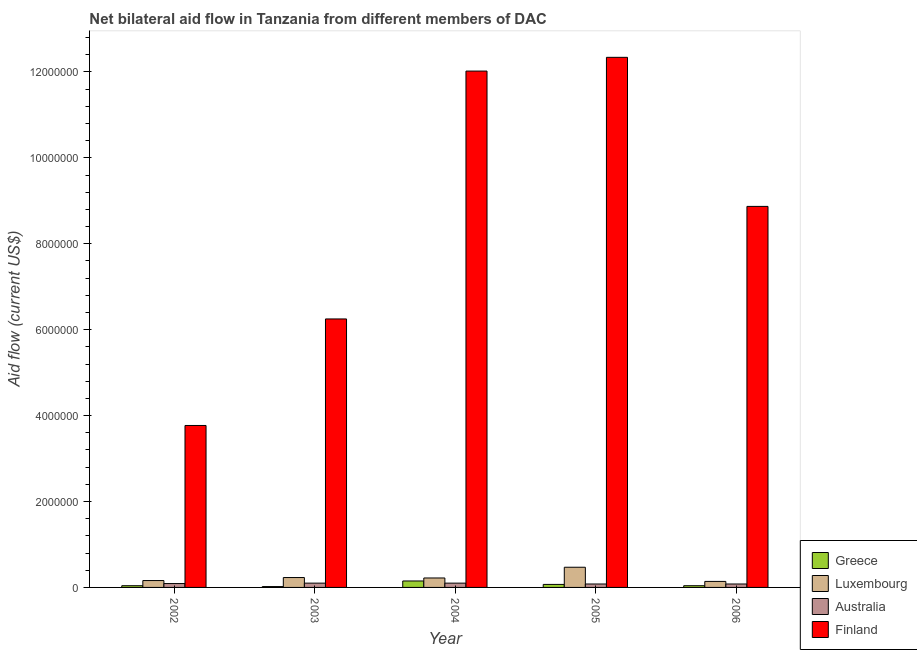How many different coloured bars are there?
Your answer should be compact. 4. How many groups of bars are there?
Provide a succinct answer. 5. Are the number of bars on each tick of the X-axis equal?
Provide a short and direct response. Yes. How many bars are there on the 4th tick from the left?
Give a very brief answer. 4. What is the label of the 3rd group of bars from the left?
Make the answer very short. 2004. In how many cases, is the number of bars for a given year not equal to the number of legend labels?
Your response must be concise. 0. What is the amount of aid given by finland in 2003?
Provide a short and direct response. 6.25e+06. Across all years, what is the maximum amount of aid given by luxembourg?
Offer a very short reply. 4.70e+05. Across all years, what is the minimum amount of aid given by australia?
Your answer should be compact. 8.00e+04. In which year was the amount of aid given by greece minimum?
Offer a terse response. 2003. What is the total amount of aid given by australia in the graph?
Provide a succinct answer. 4.50e+05. What is the difference between the amount of aid given by finland in 2002 and that in 2004?
Provide a succinct answer. -8.25e+06. What is the average amount of aid given by luxembourg per year?
Give a very brief answer. 2.44e+05. In the year 2004, what is the difference between the amount of aid given by luxembourg and amount of aid given by australia?
Provide a succinct answer. 0. What is the difference between the highest and the lowest amount of aid given by luxembourg?
Your answer should be very brief. 3.30e+05. In how many years, is the amount of aid given by australia greater than the average amount of aid given by australia taken over all years?
Offer a terse response. 2. Is the sum of the amount of aid given by greece in 2002 and 2004 greater than the maximum amount of aid given by luxembourg across all years?
Offer a terse response. Yes. How many bars are there?
Ensure brevity in your answer.  20. Does the graph contain any zero values?
Provide a succinct answer. No. Does the graph contain grids?
Provide a succinct answer. No. What is the title of the graph?
Your answer should be very brief. Net bilateral aid flow in Tanzania from different members of DAC. What is the Aid flow (current US$) in Luxembourg in 2002?
Give a very brief answer. 1.60e+05. What is the Aid flow (current US$) of Australia in 2002?
Provide a succinct answer. 9.00e+04. What is the Aid flow (current US$) in Finland in 2002?
Your answer should be compact. 3.77e+06. What is the Aid flow (current US$) of Australia in 2003?
Offer a terse response. 1.00e+05. What is the Aid flow (current US$) of Finland in 2003?
Provide a short and direct response. 6.25e+06. What is the Aid flow (current US$) in Luxembourg in 2004?
Ensure brevity in your answer.  2.20e+05. What is the Aid flow (current US$) of Finland in 2004?
Keep it short and to the point. 1.20e+07. What is the Aid flow (current US$) of Finland in 2005?
Offer a very short reply. 1.23e+07. What is the Aid flow (current US$) in Finland in 2006?
Give a very brief answer. 8.87e+06. Across all years, what is the maximum Aid flow (current US$) of Greece?
Your answer should be compact. 1.50e+05. Across all years, what is the maximum Aid flow (current US$) in Finland?
Make the answer very short. 1.23e+07. Across all years, what is the minimum Aid flow (current US$) in Finland?
Your answer should be very brief. 3.77e+06. What is the total Aid flow (current US$) in Greece in the graph?
Give a very brief answer. 3.20e+05. What is the total Aid flow (current US$) of Luxembourg in the graph?
Provide a short and direct response. 1.22e+06. What is the total Aid flow (current US$) in Finland in the graph?
Offer a terse response. 4.32e+07. What is the difference between the Aid flow (current US$) of Greece in 2002 and that in 2003?
Ensure brevity in your answer.  2.00e+04. What is the difference between the Aid flow (current US$) in Luxembourg in 2002 and that in 2003?
Provide a succinct answer. -7.00e+04. What is the difference between the Aid flow (current US$) in Finland in 2002 and that in 2003?
Ensure brevity in your answer.  -2.48e+06. What is the difference between the Aid flow (current US$) of Luxembourg in 2002 and that in 2004?
Your answer should be compact. -6.00e+04. What is the difference between the Aid flow (current US$) of Australia in 2002 and that in 2004?
Provide a succinct answer. -10000. What is the difference between the Aid flow (current US$) in Finland in 2002 and that in 2004?
Provide a short and direct response. -8.25e+06. What is the difference between the Aid flow (current US$) in Luxembourg in 2002 and that in 2005?
Ensure brevity in your answer.  -3.10e+05. What is the difference between the Aid flow (current US$) of Finland in 2002 and that in 2005?
Make the answer very short. -8.57e+06. What is the difference between the Aid flow (current US$) of Greece in 2002 and that in 2006?
Ensure brevity in your answer.  0. What is the difference between the Aid flow (current US$) of Finland in 2002 and that in 2006?
Your answer should be very brief. -5.10e+06. What is the difference between the Aid flow (current US$) in Greece in 2003 and that in 2004?
Give a very brief answer. -1.30e+05. What is the difference between the Aid flow (current US$) of Australia in 2003 and that in 2004?
Your response must be concise. 0. What is the difference between the Aid flow (current US$) of Finland in 2003 and that in 2004?
Make the answer very short. -5.77e+06. What is the difference between the Aid flow (current US$) of Finland in 2003 and that in 2005?
Your answer should be compact. -6.09e+06. What is the difference between the Aid flow (current US$) in Greece in 2003 and that in 2006?
Ensure brevity in your answer.  -2.00e+04. What is the difference between the Aid flow (current US$) of Australia in 2003 and that in 2006?
Provide a succinct answer. 2.00e+04. What is the difference between the Aid flow (current US$) in Finland in 2003 and that in 2006?
Keep it short and to the point. -2.62e+06. What is the difference between the Aid flow (current US$) in Greece in 2004 and that in 2005?
Offer a terse response. 8.00e+04. What is the difference between the Aid flow (current US$) of Luxembourg in 2004 and that in 2005?
Your answer should be compact. -2.50e+05. What is the difference between the Aid flow (current US$) in Finland in 2004 and that in 2005?
Provide a succinct answer. -3.20e+05. What is the difference between the Aid flow (current US$) of Finland in 2004 and that in 2006?
Provide a short and direct response. 3.15e+06. What is the difference between the Aid flow (current US$) in Greece in 2005 and that in 2006?
Offer a terse response. 3.00e+04. What is the difference between the Aid flow (current US$) in Australia in 2005 and that in 2006?
Your response must be concise. 0. What is the difference between the Aid flow (current US$) of Finland in 2005 and that in 2006?
Your answer should be compact. 3.47e+06. What is the difference between the Aid flow (current US$) in Greece in 2002 and the Aid flow (current US$) in Luxembourg in 2003?
Offer a very short reply. -1.90e+05. What is the difference between the Aid flow (current US$) of Greece in 2002 and the Aid flow (current US$) of Finland in 2003?
Provide a succinct answer. -6.21e+06. What is the difference between the Aid flow (current US$) of Luxembourg in 2002 and the Aid flow (current US$) of Australia in 2003?
Your response must be concise. 6.00e+04. What is the difference between the Aid flow (current US$) in Luxembourg in 2002 and the Aid flow (current US$) in Finland in 2003?
Give a very brief answer. -6.09e+06. What is the difference between the Aid flow (current US$) in Australia in 2002 and the Aid flow (current US$) in Finland in 2003?
Provide a succinct answer. -6.16e+06. What is the difference between the Aid flow (current US$) in Greece in 2002 and the Aid flow (current US$) in Australia in 2004?
Keep it short and to the point. -6.00e+04. What is the difference between the Aid flow (current US$) in Greece in 2002 and the Aid flow (current US$) in Finland in 2004?
Your response must be concise. -1.20e+07. What is the difference between the Aid flow (current US$) in Luxembourg in 2002 and the Aid flow (current US$) in Finland in 2004?
Make the answer very short. -1.19e+07. What is the difference between the Aid flow (current US$) of Australia in 2002 and the Aid flow (current US$) of Finland in 2004?
Your answer should be very brief. -1.19e+07. What is the difference between the Aid flow (current US$) of Greece in 2002 and the Aid flow (current US$) of Luxembourg in 2005?
Your response must be concise. -4.30e+05. What is the difference between the Aid flow (current US$) in Greece in 2002 and the Aid flow (current US$) in Australia in 2005?
Provide a short and direct response. -4.00e+04. What is the difference between the Aid flow (current US$) in Greece in 2002 and the Aid flow (current US$) in Finland in 2005?
Offer a very short reply. -1.23e+07. What is the difference between the Aid flow (current US$) in Luxembourg in 2002 and the Aid flow (current US$) in Finland in 2005?
Make the answer very short. -1.22e+07. What is the difference between the Aid flow (current US$) of Australia in 2002 and the Aid flow (current US$) of Finland in 2005?
Your answer should be very brief. -1.22e+07. What is the difference between the Aid flow (current US$) in Greece in 2002 and the Aid flow (current US$) in Finland in 2006?
Offer a terse response. -8.83e+06. What is the difference between the Aid flow (current US$) in Luxembourg in 2002 and the Aid flow (current US$) in Finland in 2006?
Provide a short and direct response. -8.71e+06. What is the difference between the Aid flow (current US$) of Australia in 2002 and the Aid flow (current US$) of Finland in 2006?
Your answer should be very brief. -8.78e+06. What is the difference between the Aid flow (current US$) of Greece in 2003 and the Aid flow (current US$) of Australia in 2004?
Your response must be concise. -8.00e+04. What is the difference between the Aid flow (current US$) of Greece in 2003 and the Aid flow (current US$) of Finland in 2004?
Provide a short and direct response. -1.20e+07. What is the difference between the Aid flow (current US$) of Luxembourg in 2003 and the Aid flow (current US$) of Australia in 2004?
Keep it short and to the point. 1.30e+05. What is the difference between the Aid flow (current US$) in Luxembourg in 2003 and the Aid flow (current US$) in Finland in 2004?
Ensure brevity in your answer.  -1.18e+07. What is the difference between the Aid flow (current US$) of Australia in 2003 and the Aid flow (current US$) of Finland in 2004?
Keep it short and to the point. -1.19e+07. What is the difference between the Aid flow (current US$) in Greece in 2003 and the Aid flow (current US$) in Luxembourg in 2005?
Keep it short and to the point. -4.50e+05. What is the difference between the Aid flow (current US$) of Greece in 2003 and the Aid flow (current US$) of Finland in 2005?
Provide a succinct answer. -1.23e+07. What is the difference between the Aid flow (current US$) of Luxembourg in 2003 and the Aid flow (current US$) of Finland in 2005?
Your response must be concise. -1.21e+07. What is the difference between the Aid flow (current US$) of Australia in 2003 and the Aid flow (current US$) of Finland in 2005?
Your answer should be compact. -1.22e+07. What is the difference between the Aid flow (current US$) in Greece in 2003 and the Aid flow (current US$) in Luxembourg in 2006?
Offer a very short reply. -1.20e+05. What is the difference between the Aid flow (current US$) of Greece in 2003 and the Aid flow (current US$) of Finland in 2006?
Your answer should be compact. -8.85e+06. What is the difference between the Aid flow (current US$) of Luxembourg in 2003 and the Aid flow (current US$) of Finland in 2006?
Keep it short and to the point. -8.64e+06. What is the difference between the Aid flow (current US$) of Australia in 2003 and the Aid flow (current US$) of Finland in 2006?
Offer a very short reply. -8.77e+06. What is the difference between the Aid flow (current US$) in Greece in 2004 and the Aid flow (current US$) in Luxembourg in 2005?
Provide a short and direct response. -3.20e+05. What is the difference between the Aid flow (current US$) in Greece in 2004 and the Aid flow (current US$) in Australia in 2005?
Keep it short and to the point. 7.00e+04. What is the difference between the Aid flow (current US$) in Greece in 2004 and the Aid flow (current US$) in Finland in 2005?
Provide a succinct answer. -1.22e+07. What is the difference between the Aid flow (current US$) in Luxembourg in 2004 and the Aid flow (current US$) in Australia in 2005?
Give a very brief answer. 1.40e+05. What is the difference between the Aid flow (current US$) in Luxembourg in 2004 and the Aid flow (current US$) in Finland in 2005?
Offer a very short reply. -1.21e+07. What is the difference between the Aid flow (current US$) in Australia in 2004 and the Aid flow (current US$) in Finland in 2005?
Your answer should be very brief. -1.22e+07. What is the difference between the Aid flow (current US$) of Greece in 2004 and the Aid flow (current US$) of Australia in 2006?
Keep it short and to the point. 7.00e+04. What is the difference between the Aid flow (current US$) in Greece in 2004 and the Aid flow (current US$) in Finland in 2006?
Your answer should be very brief. -8.72e+06. What is the difference between the Aid flow (current US$) in Luxembourg in 2004 and the Aid flow (current US$) in Finland in 2006?
Your answer should be compact. -8.65e+06. What is the difference between the Aid flow (current US$) of Australia in 2004 and the Aid flow (current US$) of Finland in 2006?
Offer a very short reply. -8.77e+06. What is the difference between the Aid flow (current US$) of Greece in 2005 and the Aid flow (current US$) of Finland in 2006?
Your answer should be compact. -8.80e+06. What is the difference between the Aid flow (current US$) of Luxembourg in 2005 and the Aid flow (current US$) of Finland in 2006?
Give a very brief answer. -8.40e+06. What is the difference between the Aid flow (current US$) in Australia in 2005 and the Aid flow (current US$) in Finland in 2006?
Provide a short and direct response. -8.79e+06. What is the average Aid flow (current US$) in Greece per year?
Give a very brief answer. 6.40e+04. What is the average Aid flow (current US$) in Luxembourg per year?
Provide a short and direct response. 2.44e+05. What is the average Aid flow (current US$) of Finland per year?
Keep it short and to the point. 8.65e+06. In the year 2002, what is the difference between the Aid flow (current US$) in Greece and Aid flow (current US$) in Australia?
Keep it short and to the point. -5.00e+04. In the year 2002, what is the difference between the Aid flow (current US$) of Greece and Aid flow (current US$) of Finland?
Provide a short and direct response. -3.73e+06. In the year 2002, what is the difference between the Aid flow (current US$) in Luxembourg and Aid flow (current US$) in Finland?
Give a very brief answer. -3.61e+06. In the year 2002, what is the difference between the Aid flow (current US$) in Australia and Aid flow (current US$) in Finland?
Your response must be concise. -3.68e+06. In the year 2003, what is the difference between the Aid flow (current US$) in Greece and Aid flow (current US$) in Luxembourg?
Provide a succinct answer. -2.10e+05. In the year 2003, what is the difference between the Aid flow (current US$) of Greece and Aid flow (current US$) of Finland?
Your response must be concise. -6.23e+06. In the year 2003, what is the difference between the Aid flow (current US$) in Luxembourg and Aid flow (current US$) in Finland?
Keep it short and to the point. -6.02e+06. In the year 2003, what is the difference between the Aid flow (current US$) in Australia and Aid flow (current US$) in Finland?
Offer a terse response. -6.15e+06. In the year 2004, what is the difference between the Aid flow (current US$) of Greece and Aid flow (current US$) of Australia?
Make the answer very short. 5.00e+04. In the year 2004, what is the difference between the Aid flow (current US$) of Greece and Aid flow (current US$) of Finland?
Offer a terse response. -1.19e+07. In the year 2004, what is the difference between the Aid flow (current US$) of Luxembourg and Aid flow (current US$) of Australia?
Give a very brief answer. 1.20e+05. In the year 2004, what is the difference between the Aid flow (current US$) of Luxembourg and Aid flow (current US$) of Finland?
Your answer should be very brief. -1.18e+07. In the year 2004, what is the difference between the Aid flow (current US$) of Australia and Aid flow (current US$) of Finland?
Your response must be concise. -1.19e+07. In the year 2005, what is the difference between the Aid flow (current US$) in Greece and Aid flow (current US$) in Luxembourg?
Offer a very short reply. -4.00e+05. In the year 2005, what is the difference between the Aid flow (current US$) of Greece and Aid flow (current US$) of Finland?
Keep it short and to the point. -1.23e+07. In the year 2005, what is the difference between the Aid flow (current US$) of Luxembourg and Aid flow (current US$) of Australia?
Keep it short and to the point. 3.90e+05. In the year 2005, what is the difference between the Aid flow (current US$) of Luxembourg and Aid flow (current US$) of Finland?
Offer a very short reply. -1.19e+07. In the year 2005, what is the difference between the Aid flow (current US$) in Australia and Aid flow (current US$) in Finland?
Provide a succinct answer. -1.23e+07. In the year 2006, what is the difference between the Aid flow (current US$) of Greece and Aid flow (current US$) of Finland?
Offer a very short reply. -8.83e+06. In the year 2006, what is the difference between the Aid flow (current US$) in Luxembourg and Aid flow (current US$) in Finland?
Make the answer very short. -8.73e+06. In the year 2006, what is the difference between the Aid flow (current US$) of Australia and Aid flow (current US$) of Finland?
Offer a very short reply. -8.79e+06. What is the ratio of the Aid flow (current US$) in Luxembourg in 2002 to that in 2003?
Make the answer very short. 0.7. What is the ratio of the Aid flow (current US$) in Finland in 2002 to that in 2003?
Your response must be concise. 0.6. What is the ratio of the Aid flow (current US$) in Greece in 2002 to that in 2004?
Your answer should be very brief. 0.27. What is the ratio of the Aid flow (current US$) in Luxembourg in 2002 to that in 2004?
Your answer should be very brief. 0.73. What is the ratio of the Aid flow (current US$) of Australia in 2002 to that in 2004?
Your response must be concise. 0.9. What is the ratio of the Aid flow (current US$) in Finland in 2002 to that in 2004?
Give a very brief answer. 0.31. What is the ratio of the Aid flow (current US$) of Luxembourg in 2002 to that in 2005?
Your response must be concise. 0.34. What is the ratio of the Aid flow (current US$) of Finland in 2002 to that in 2005?
Make the answer very short. 0.31. What is the ratio of the Aid flow (current US$) of Australia in 2002 to that in 2006?
Offer a terse response. 1.12. What is the ratio of the Aid flow (current US$) in Finland in 2002 to that in 2006?
Provide a succinct answer. 0.42. What is the ratio of the Aid flow (current US$) in Greece in 2003 to that in 2004?
Provide a short and direct response. 0.13. What is the ratio of the Aid flow (current US$) in Luxembourg in 2003 to that in 2004?
Provide a succinct answer. 1.05. What is the ratio of the Aid flow (current US$) of Australia in 2003 to that in 2004?
Offer a terse response. 1. What is the ratio of the Aid flow (current US$) of Finland in 2003 to that in 2004?
Offer a terse response. 0.52. What is the ratio of the Aid flow (current US$) in Greece in 2003 to that in 2005?
Provide a succinct answer. 0.29. What is the ratio of the Aid flow (current US$) in Luxembourg in 2003 to that in 2005?
Provide a succinct answer. 0.49. What is the ratio of the Aid flow (current US$) in Australia in 2003 to that in 2005?
Give a very brief answer. 1.25. What is the ratio of the Aid flow (current US$) in Finland in 2003 to that in 2005?
Ensure brevity in your answer.  0.51. What is the ratio of the Aid flow (current US$) of Luxembourg in 2003 to that in 2006?
Your answer should be compact. 1.64. What is the ratio of the Aid flow (current US$) of Australia in 2003 to that in 2006?
Keep it short and to the point. 1.25. What is the ratio of the Aid flow (current US$) of Finland in 2003 to that in 2006?
Your answer should be compact. 0.7. What is the ratio of the Aid flow (current US$) in Greece in 2004 to that in 2005?
Your response must be concise. 2.14. What is the ratio of the Aid flow (current US$) in Luxembourg in 2004 to that in 2005?
Keep it short and to the point. 0.47. What is the ratio of the Aid flow (current US$) in Finland in 2004 to that in 2005?
Your response must be concise. 0.97. What is the ratio of the Aid flow (current US$) of Greece in 2004 to that in 2006?
Your answer should be very brief. 3.75. What is the ratio of the Aid flow (current US$) in Luxembourg in 2004 to that in 2006?
Your response must be concise. 1.57. What is the ratio of the Aid flow (current US$) in Finland in 2004 to that in 2006?
Keep it short and to the point. 1.36. What is the ratio of the Aid flow (current US$) in Luxembourg in 2005 to that in 2006?
Offer a terse response. 3.36. What is the ratio of the Aid flow (current US$) of Finland in 2005 to that in 2006?
Offer a terse response. 1.39. What is the difference between the highest and the second highest Aid flow (current US$) of Luxembourg?
Your response must be concise. 2.40e+05. What is the difference between the highest and the second highest Aid flow (current US$) of Australia?
Your answer should be very brief. 0. What is the difference between the highest and the lowest Aid flow (current US$) in Luxembourg?
Ensure brevity in your answer.  3.30e+05. What is the difference between the highest and the lowest Aid flow (current US$) of Finland?
Your response must be concise. 8.57e+06. 